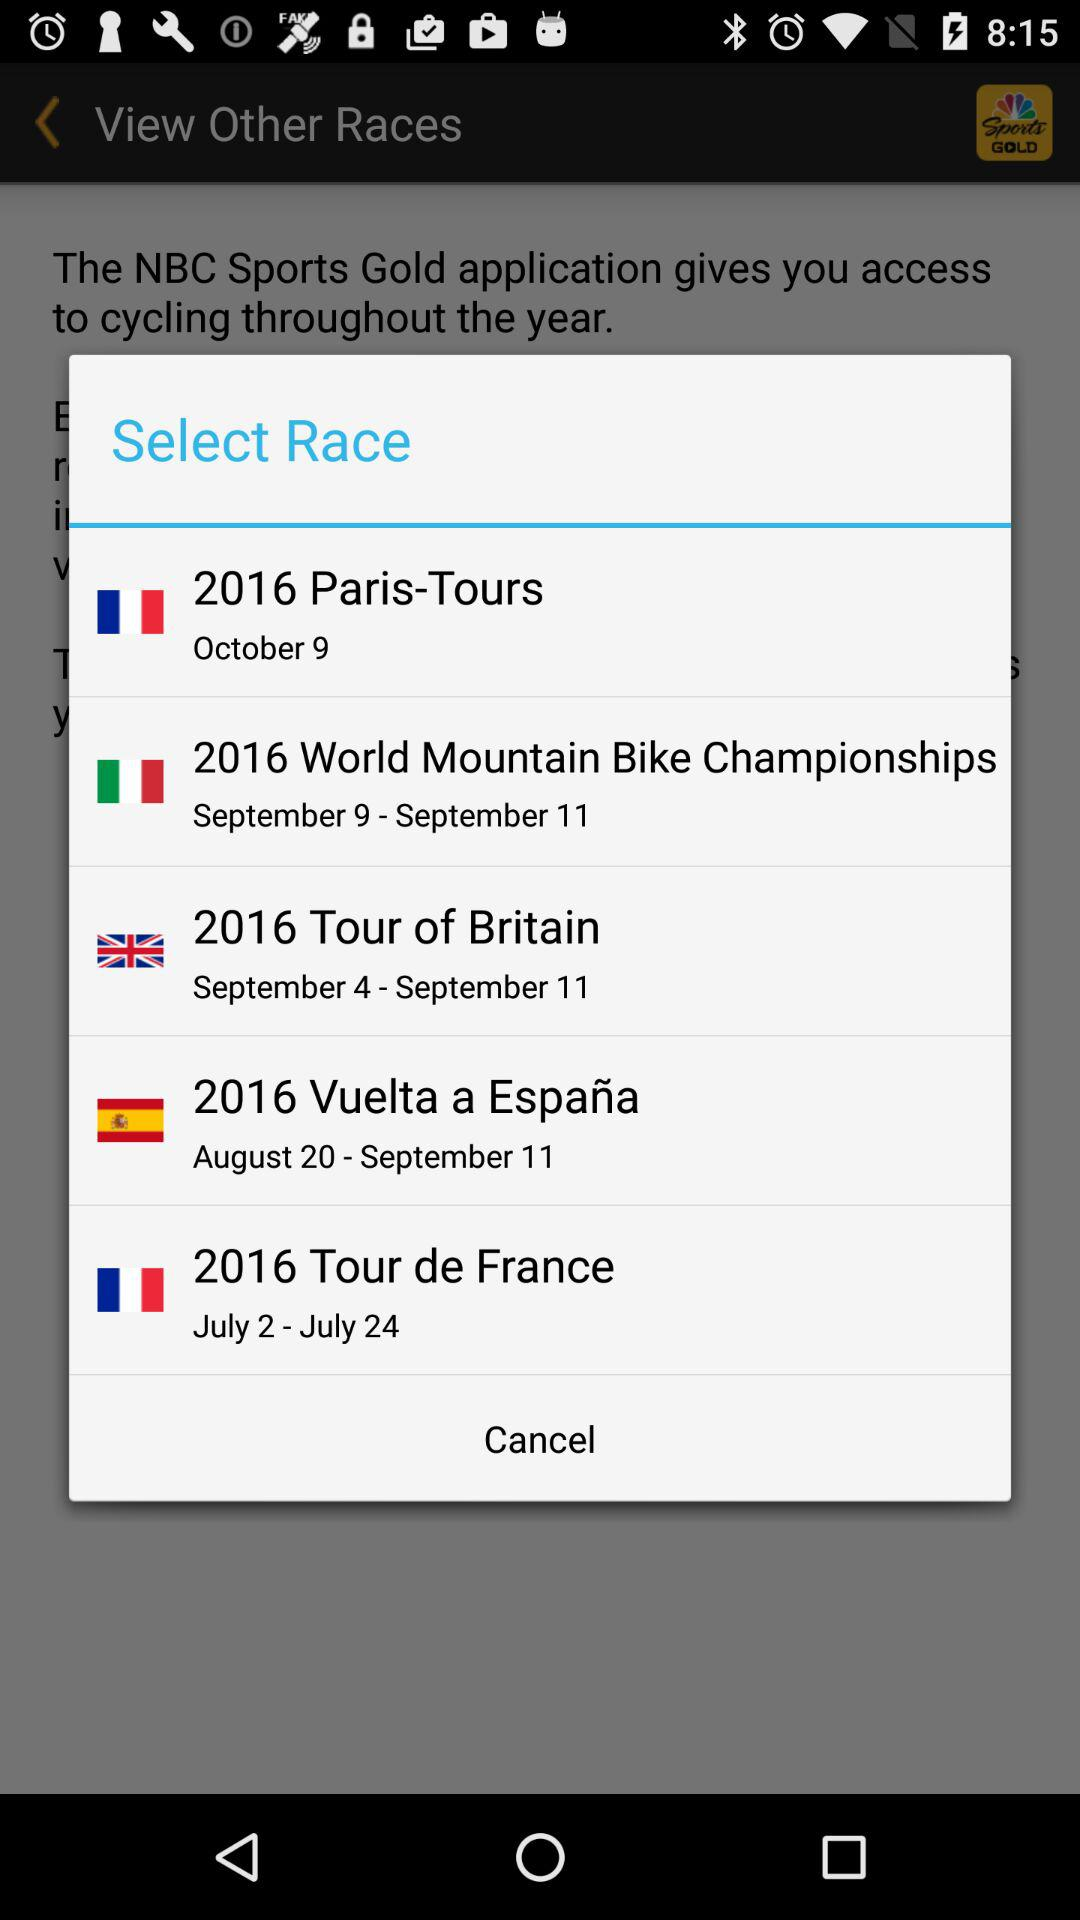On which date will the 2016 World Mountain Bike Championships be held? The 2016 World Mountain Bike Championships will be held from September 9 to September 11. 